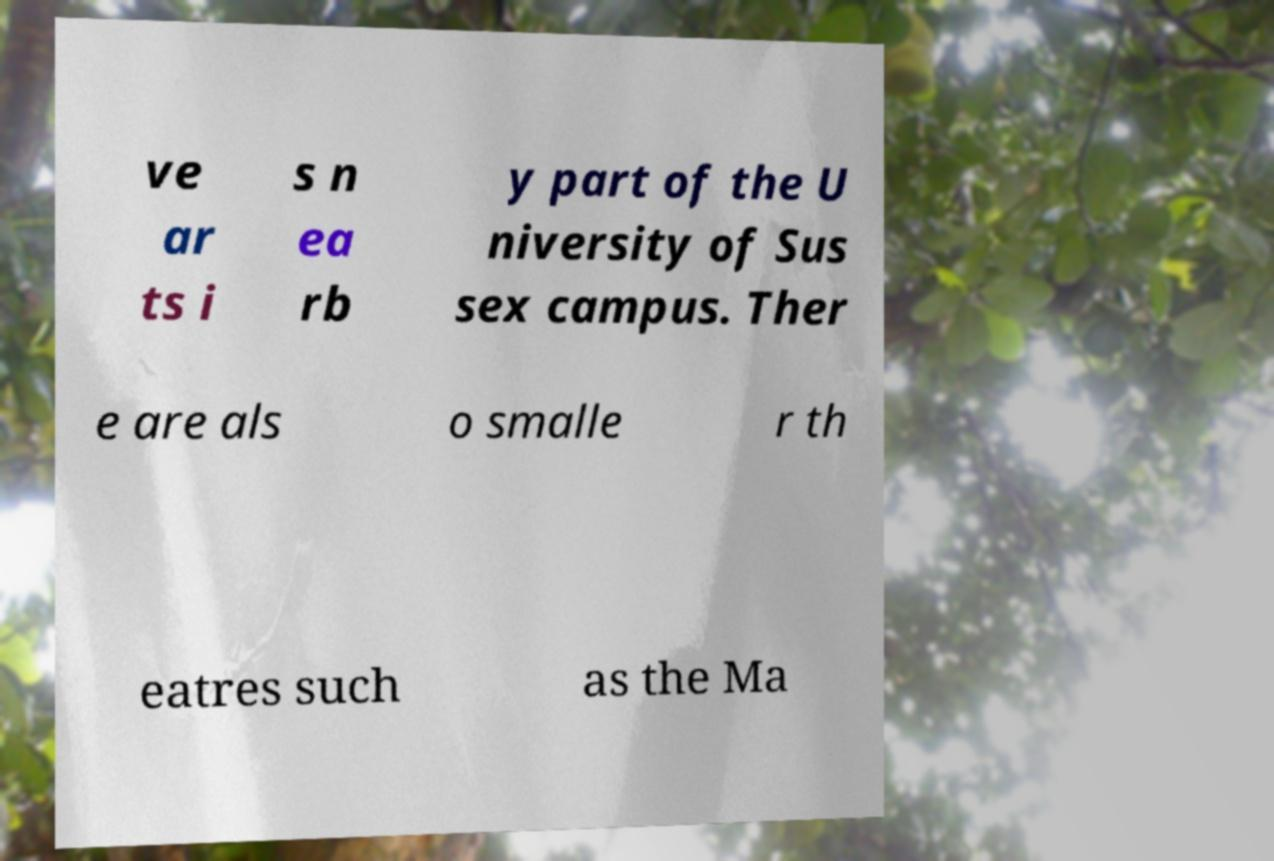Can you read and provide the text displayed in the image?This photo seems to have some interesting text. Can you extract and type it out for me? ve ar ts i s n ea rb y part of the U niversity of Sus sex campus. Ther e are als o smalle r th eatres such as the Ma 